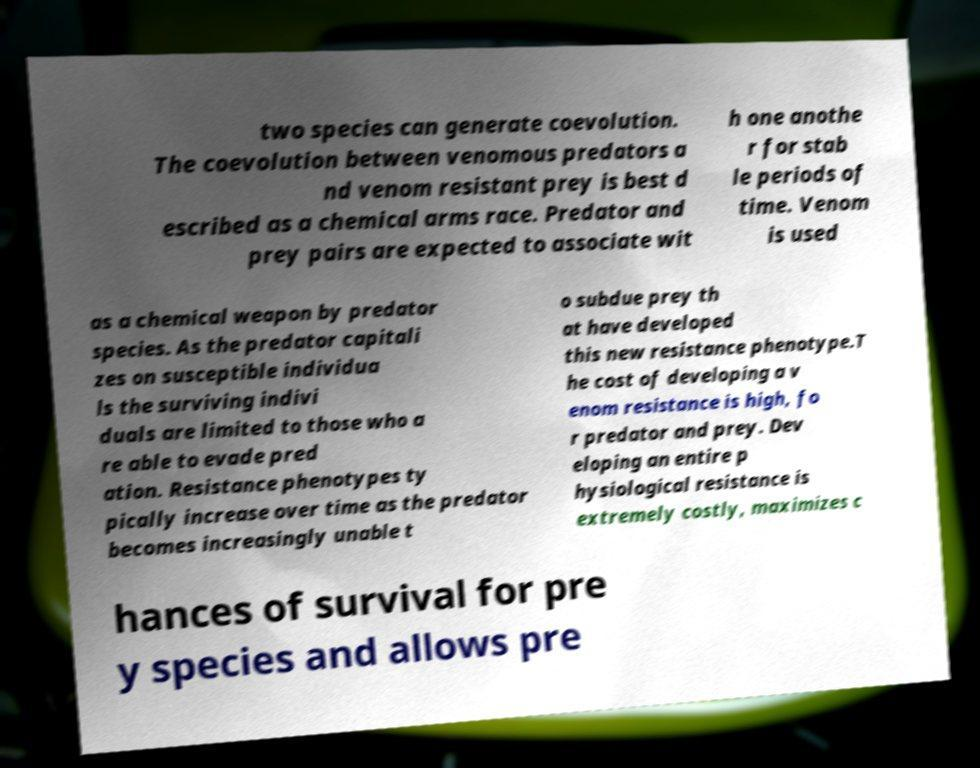Can you read and provide the text displayed in the image?This photo seems to have some interesting text. Can you extract and type it out for me? two species can generate coevolution. The coevolution between venomous predators a nd venom resistant prey is best d escribed as a chemical arms race. Predator and prey pairs are expected to associate wit h one anothe r for stab le periods of time. Venom is used as a chemical weapon by predator species. As the predator capitali zes on susceptible individua ls the surviving indivi duals are limited to those who a re able to evade pred ation. Resistance phenotypes ty pically increase over time as the predator becomes increasingly unable t o subdue prey th at have developed this new resistance phenotype.T he cost of developing a v enom resistance is high, fo r predator and prey. Dev eloping an entire p hysiological resistance is extremely costly, maximizes c hances of survival for pre y species and allows pre 